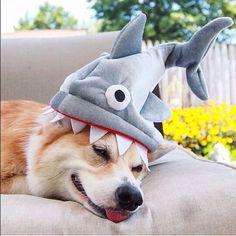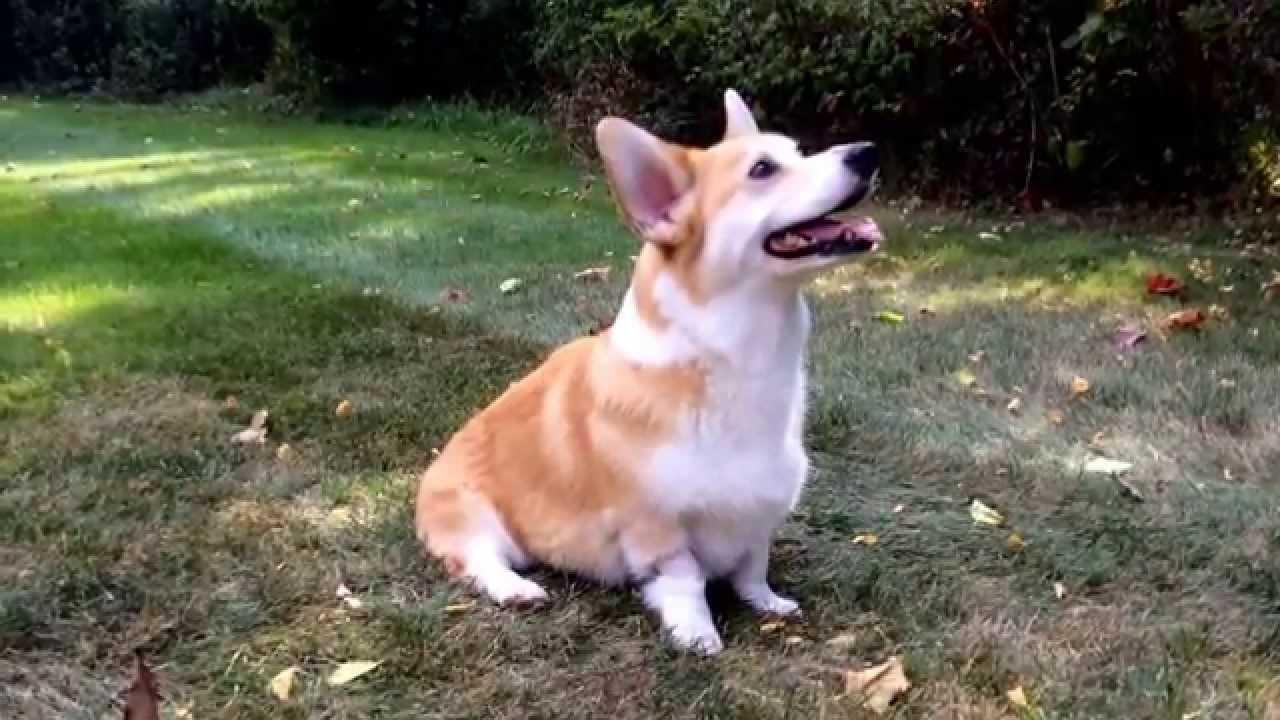The first image is the image on the left, the second image is the image on the right. Assess this claim about the two images: "The left image features one live dog posed with at least one stuffed animal figure, and the right image shows one dog that is not wearing any human-type attire.". Correct or not? Answer yes or no. Yes. The first image is the image on the left, the second image is the image on the right. Evaluate the accuracy of this statement regarding the images: "There is a dog wearing a bow tie and nothing else.". Is it true? Answer yes or no. No. 